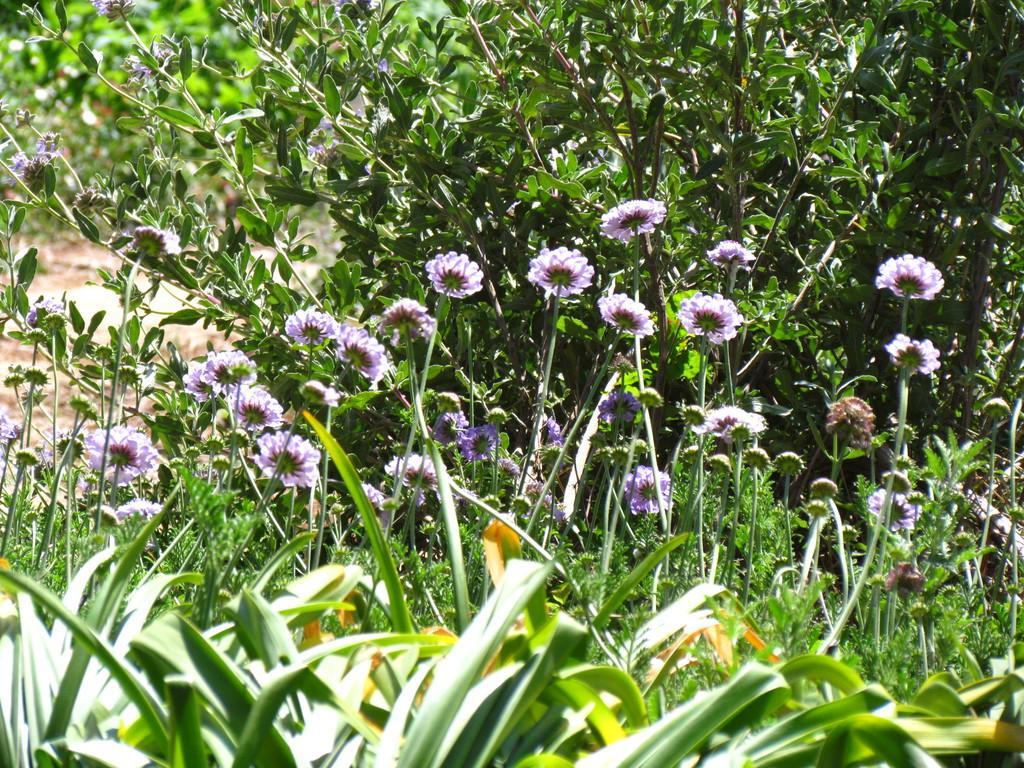Can you describe this image briefly? In this image we can see flowers, ground, and plants. 